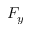<formula> <loc_0><loc_0><loc_500><loc_500>F _ { y }</formula> 